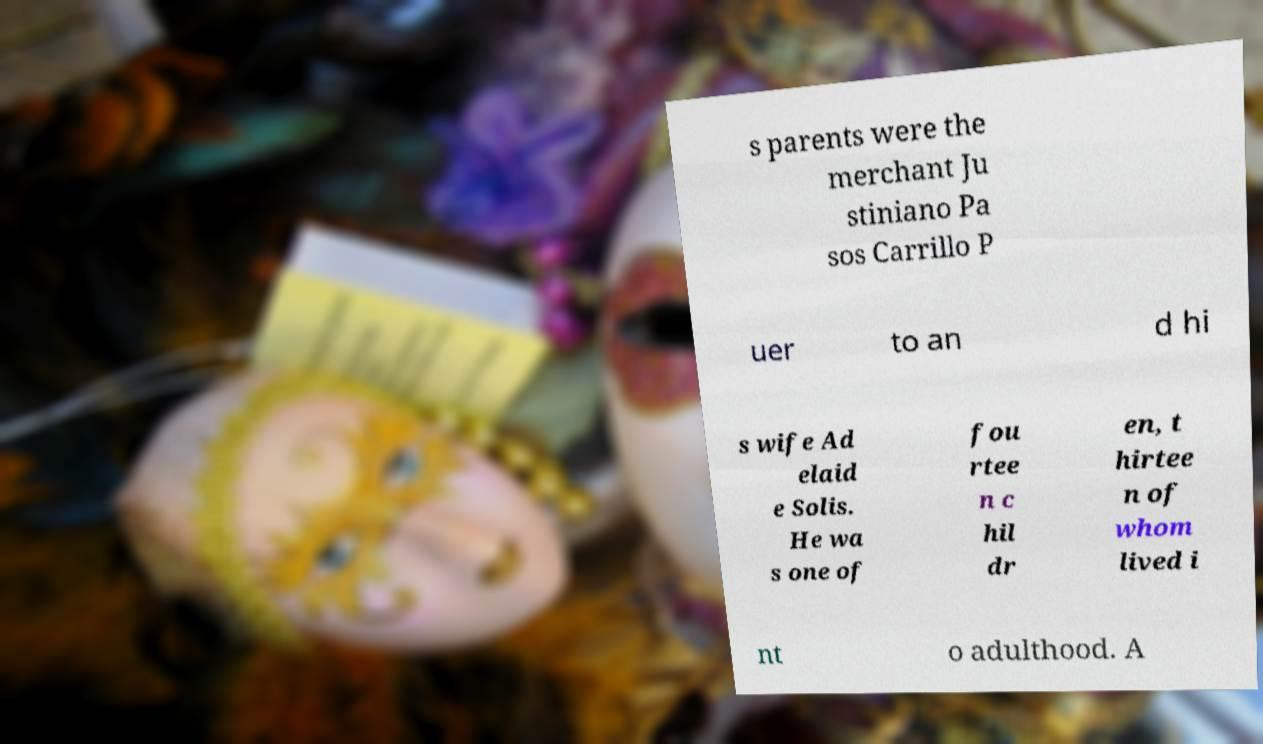For documentation purposes, I need the text within this image transcribed. Could you provide that? s parents were the merchant Ju stiniano Pa sos Carrillo P uer to an d hi s wife Ad elaid e Solis. He wa s one of fou rtee n c hil dr en, t hirtee n of whom lived i nt o adulthood. A 